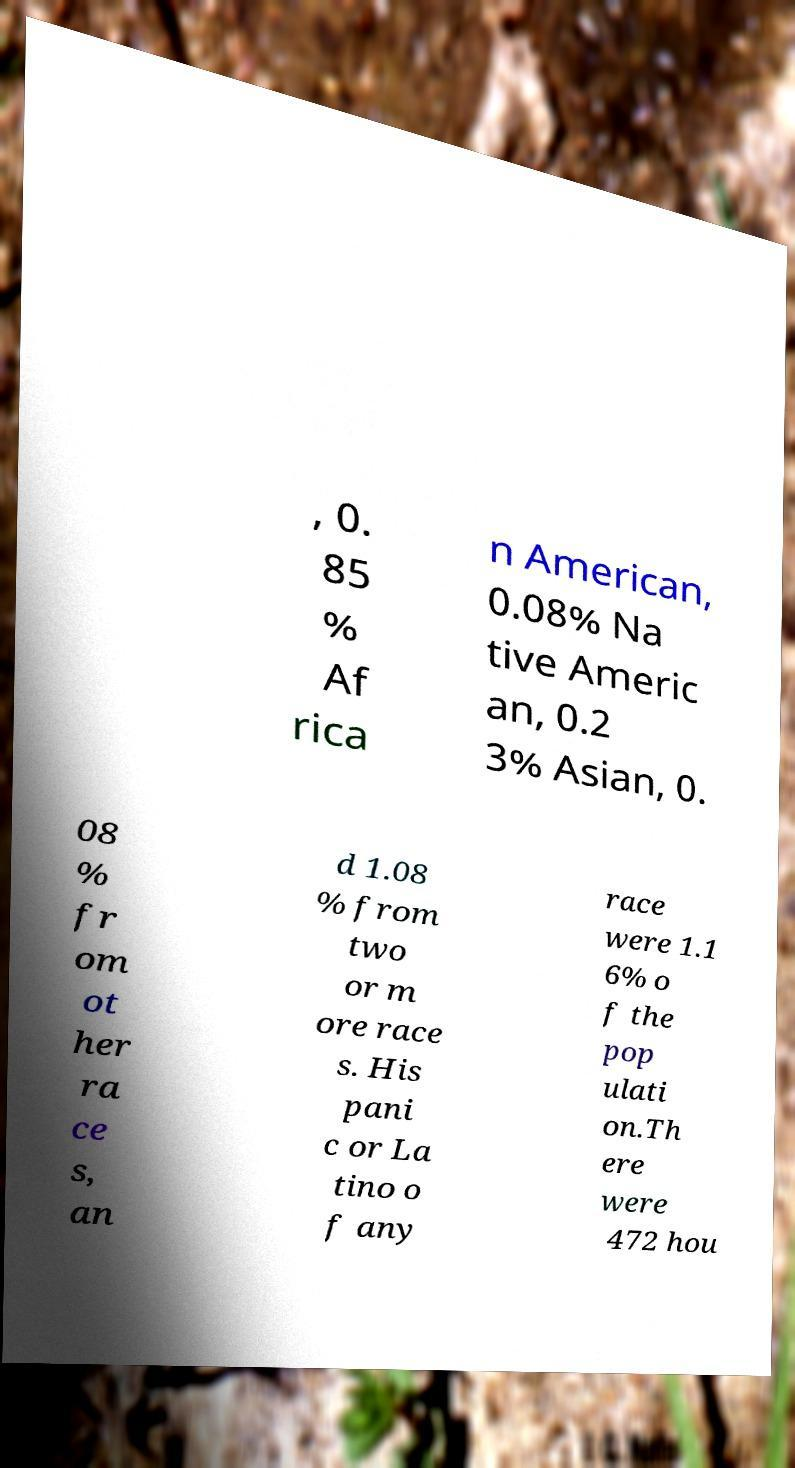Could you extract and type out the text from this image? , 0. 85 % Af rica n American, 0.08% Na tive Americ an, 0.2 3% Asian, 0. 08 % fr om ot her ra ce s, an d 1.08 % from two or m ore race s. His pani c or La tino o f any race were 1.1 6% o f the pop ulati on.Th ere were 472 hou 